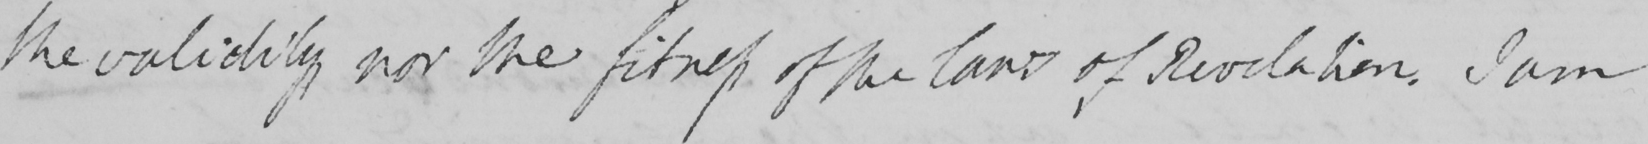What text is written in this handwritten line? the validity nor the fitness of the laws of Revelation . I am 